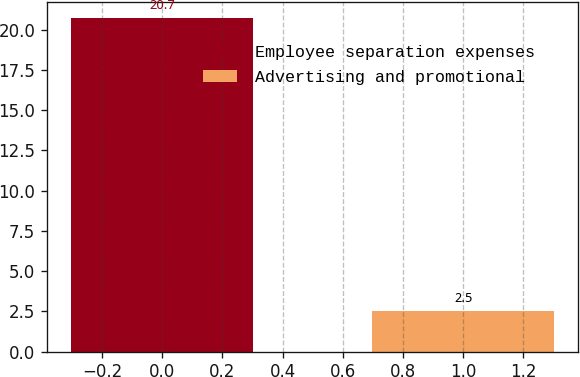<chart> <loc_0><loc_0><loc_500><loc_500><bar_chart><fcel>Employee separation expenses<fcel>Advertising and promotional<nl><fcel>20.7<fcel>2.5<nl></chart> 